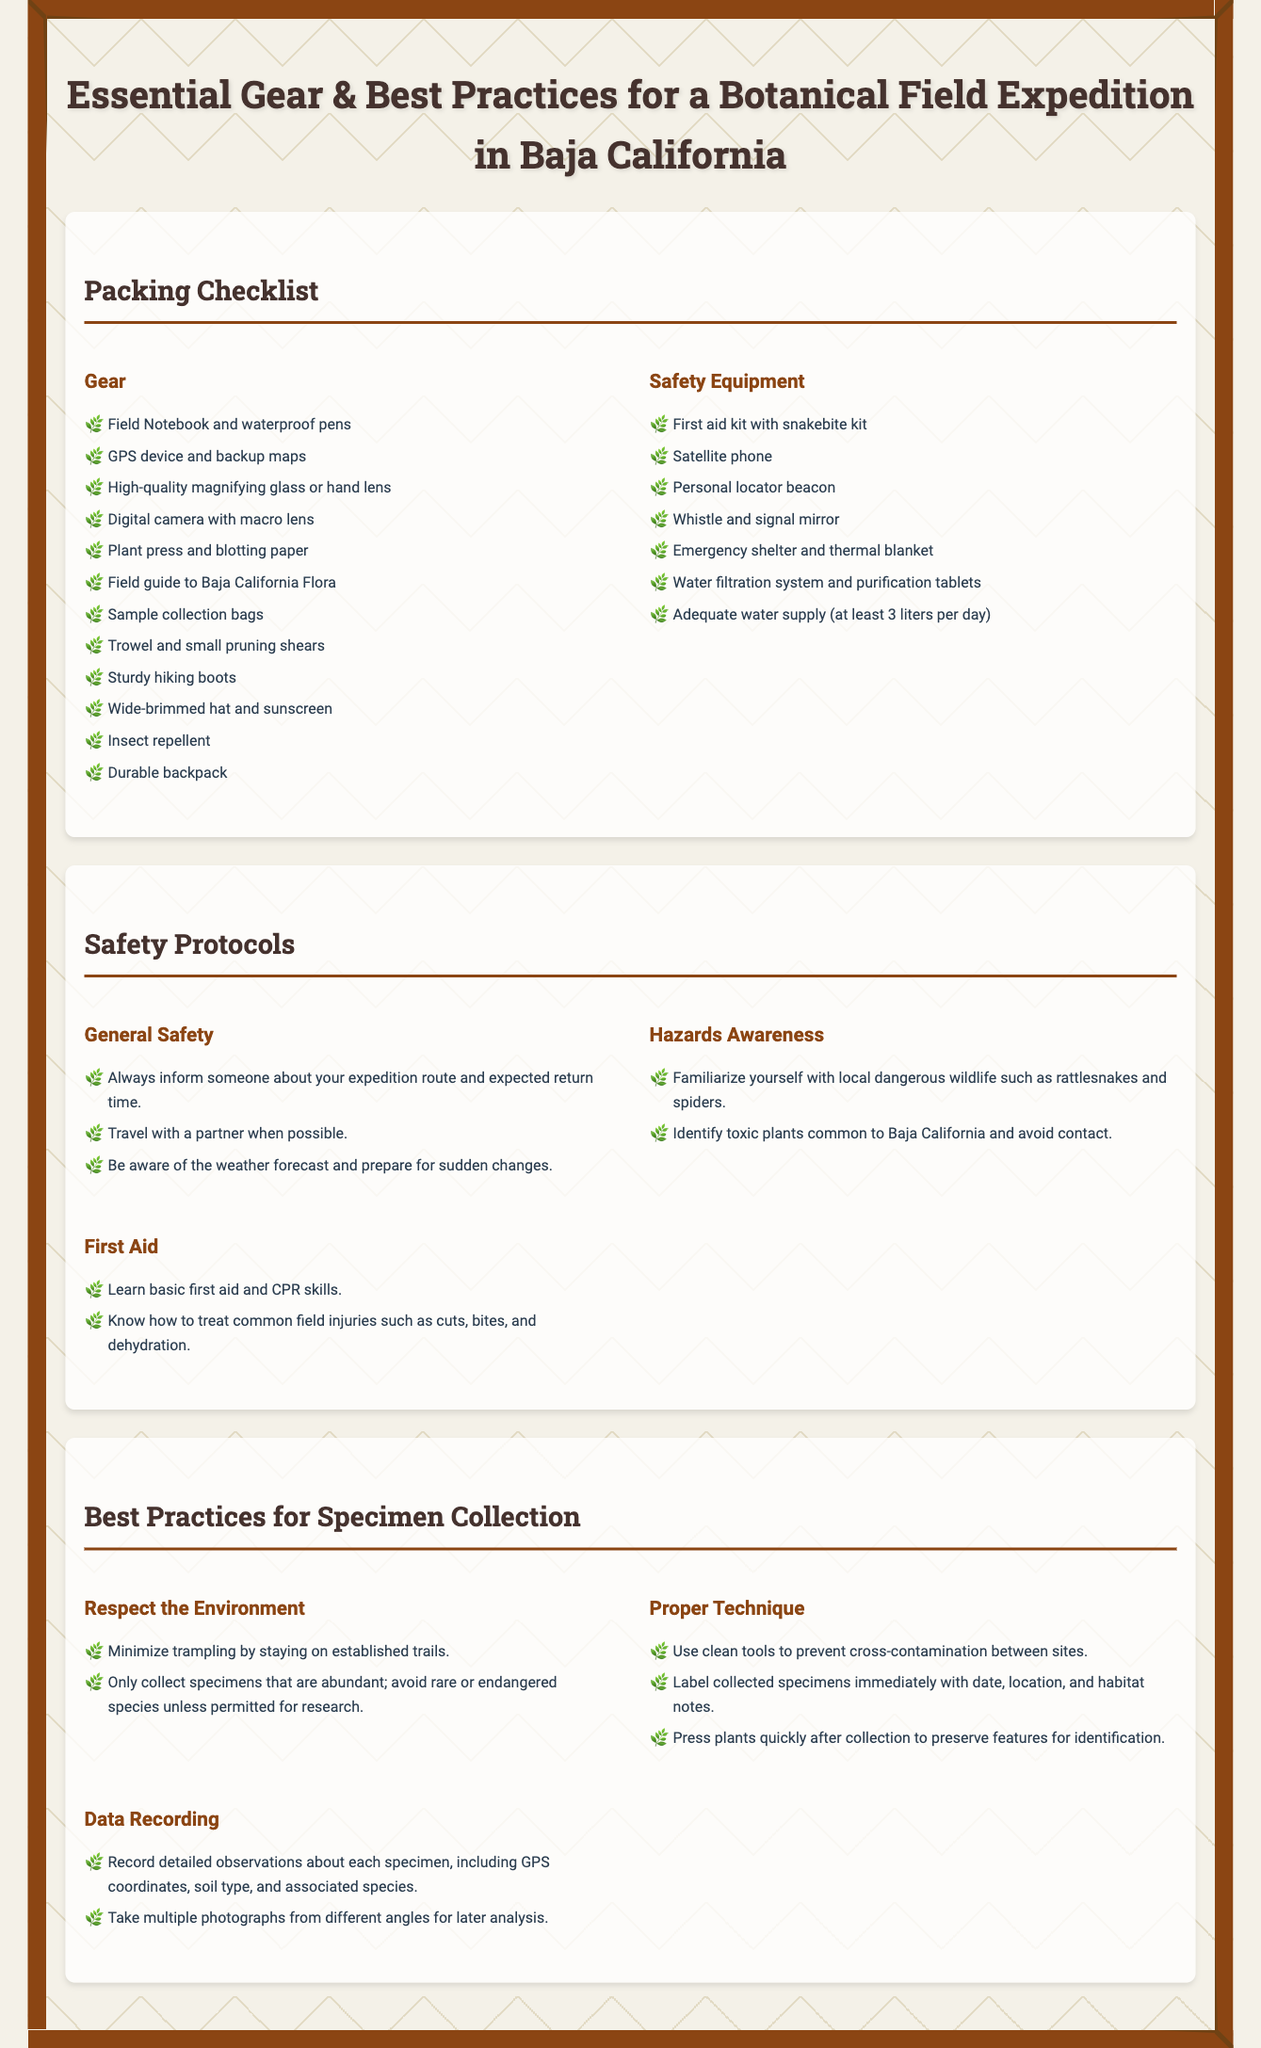what is the title of the document? The title of the document is indicated in the header section and describes its content.
Answer: Essential Gear & Best Practices for a Botanical Field Expedition in Baja California how many liters of water should you supply daily? The document specifies the necessary daily water supply for a field expedition in the safety equipment section.
Answer: at least 3 liters per day name one safety protocol related to general safety. The document lists several safety protocols that should be followed during a botanical field expedition.
Answer: Always inform someone about your expedition route and expected return time which equipment is used for collecting plant specimens? The packing checklist provides specific gear necessary for specimen collection during the expedition.
Answer: Trowel and small pruning shears what is one proper technique for specimen collection? The document highlights important techniques to ensure successful specimen collection.
Answer: Use clean tools to prevent cross-contamination between sites how many sub-sections are there in the safety protocols? To understand the complexity of the safety protocols, one can count the number of subsections provided.
Answer: 3 which type of first aid skill should one learn according to the document? The first aid subsection mentions essential skills required for handling field injuries.
Answer: basic first aid and CPR skills what should you do if a specimen is rare or endangered? The best practices section mentions precautions regarding collecting rare specimens.
Answer: avoid collecting unless permitted for research 